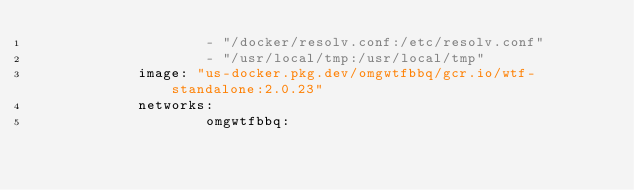<code> <loc_0><loc_0><loc_500><loc_500><_YAML_>                    - "/docker/resolv.conf:/etc/resolv.conf"
                    - "/usr/local/tmp:/usr/local/tmp"
            image: "us-docker.pkg.dev/omgwtfbbq/gcr.io/wtf-standalone:2.0.23"
            networks:
                    omgwtfbbq:</code> 